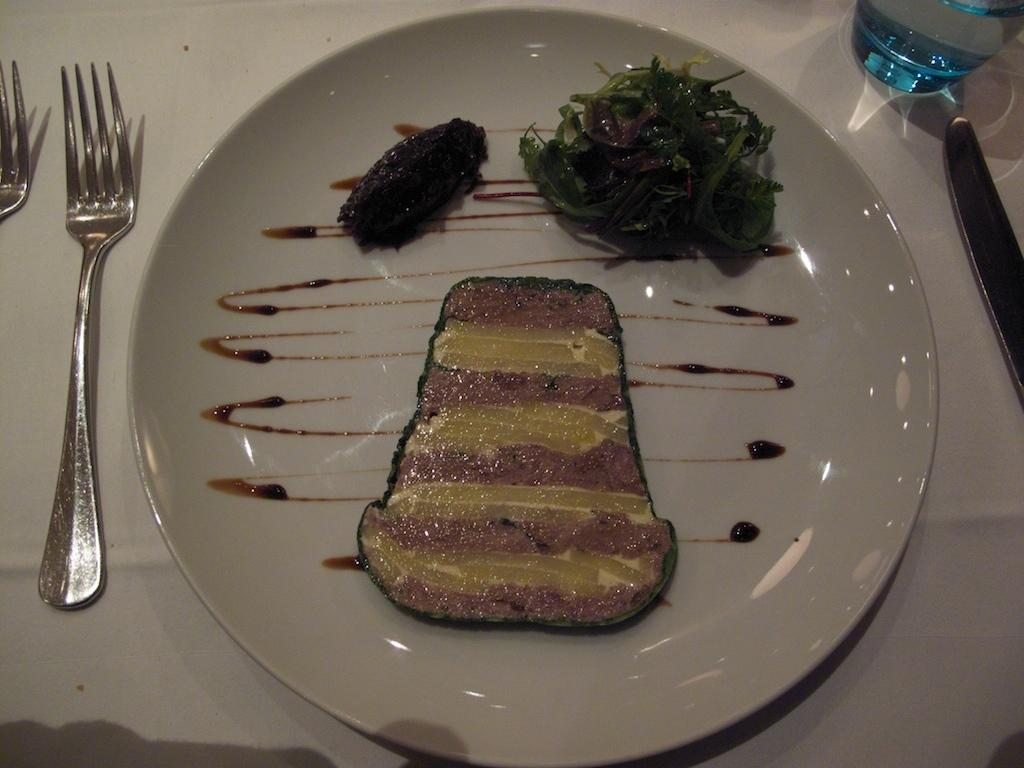What is on the plate in the image? There is a food item on a plate in the image. What utensils are near the plate? There are two forks beside the plate. What other object can be seen on the table? There is a knife on the table. What else is on the table besides the knife? There is a bottle on the table. Is there a girl sitting at the table in the image? There is no girl present in the image. What type of blade is being used to cut the food in the image? There is no blade being used to cut the food in the image; the knife is on the table but not in use. 